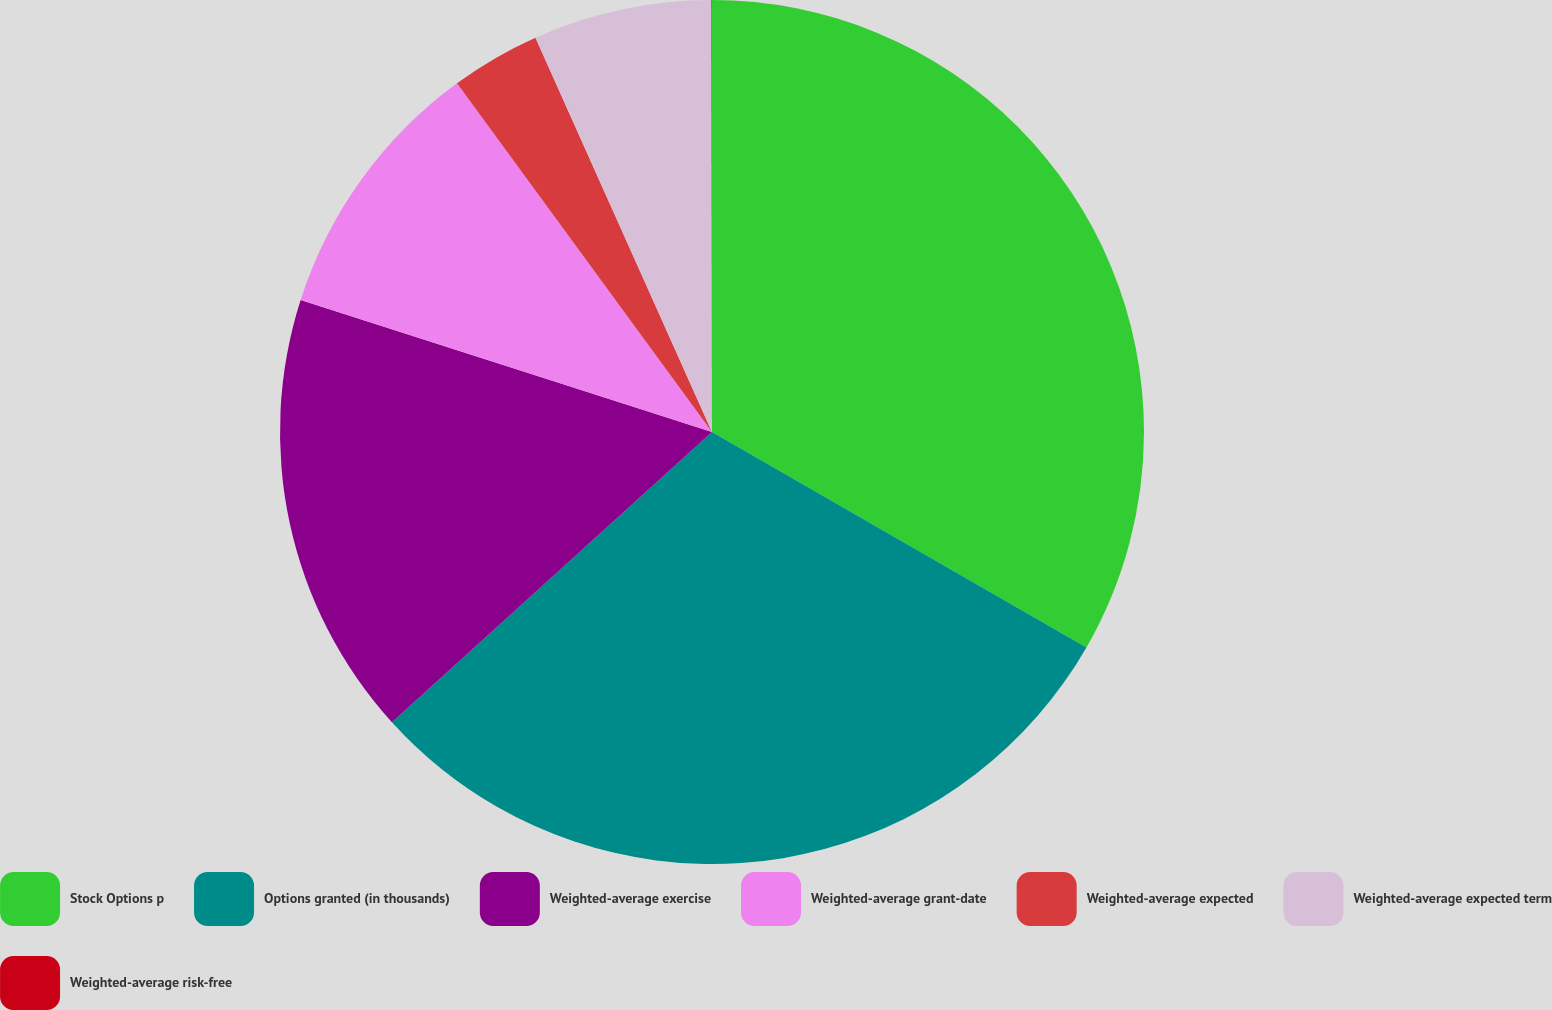<chart> <loc_0><loc_0><loc_500><loc_500><pie_chart><fcel>Stock Options p<fcel>Options granted (in thousands)<fcel>Weighted-average exercise<fcel>Weighted-average grant-date<fcel>Weighted-average expected<fcel>Weighted-average expected term<fcel>Weighted-average risk-free<nl><fcel>33.31%<fcel>29.97%<fcel>16.66%<fcel>10.01%<fcel>3.35%<fcel>6.68%<fcel>0.02%<nl></chart> 